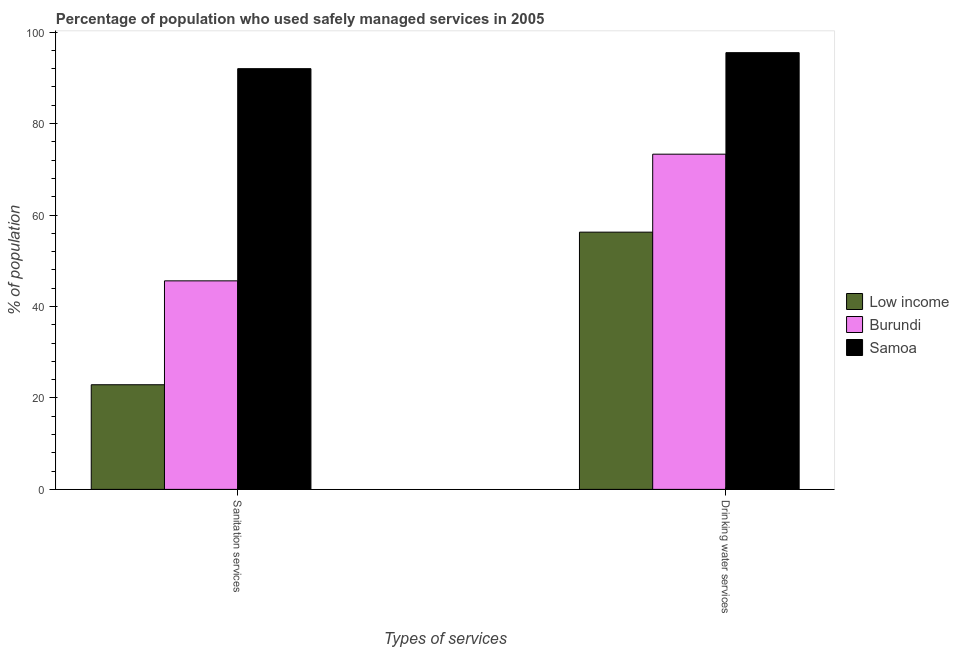How many different coloured bars are there?
Offer a very short reply. 3. How many bars are there on the 2nd tick from the right?
Provide a succinct answer. 3. What is the label of the 2nd group of bars from the left?
Offer a very short reply. Drinking water services. What is the percentage of population who used sanitation services in Samoa?
Provide a short and direct response. 92. Across all countries, what is the maximum percentage of population who used drinking water services?
Your response must be concise. 95.5. Across all countries, what is the minimum percentage of population who used sanitation services?
Offer a very short reply. 22.88. In which country was the percentage of population who used sanitation services maximum?
Give a very brief answer. Samoa. What is the total percentage of population who used sanitation services in the graph?
Your response must be concise. 160.48. What is the difference between the percentage of population who used drinking water services in Burundi and that in Samoa?
Give a very brief answer. -22.2. What is the difference between the percentage of population who used sanitation services in Burundi and the percentage of population who used drinking water services in Samoa?
Your response must be concise. -49.9. What is the average percentage of population who used drinking water services per country?
Your answer should be compact. 75.02. What is the difference between the percentage of population who used sanitation services and percentage of population who used drinking water services in Low income?
Your answer should be very brief. -33.37. What is the ratio of the percentage of population who used sanitation services in Samoa to that in Burundi?
Provide a short and direct response. 2.02. In how many countries, is the percentage of population who used drinking water services greater than the average percentage of population who used drinking water services taken over all countries?
Make the answer very short. 1. What does the 3rd bar from the left in Sanitation services represents?
Give a very brief answer. Samoa. What does the 2nd bar from the right in Sanitation services represents?
Ensure brevity in your answer.  Burundi. How many bars are there?
Make the answer very short. 6. How many countries are there in the graph?
Your response must be concise. 3. What is the difference between two consecutive major ticks on the Y-axis?
Provide a succinct answer. 20. Are the values on the major ticks of Y-axis written in scientific E-notation?
Give a very brief answer. No. Does the graph contain any zero values?
Your answer should be compact. No. Does the graph contain grids?
Make the answer very short. No. How many legend labels are there?
Your response must be concise. 3. How are the legend labels stacked?
Offer a very short reply. Vertical. What is the title of the graph?
Provide a succinct answer. Percentage of population who used safely managed services in 2005. Does "Albania" appear as one of the legend labels in the graph?
Offer a terse response. No. What is the label or title of the X-axis?
Your response must be concise. Types of services. What is the label or title of the Y-axis?
Keep it short and to the point. % of population. What is the % of population in Low income in Sanitation services?
Keep it short and to the point. 22.88. What is the % of population in Burundi in Sanitation services?
Provide a succinct answer. 45.6. What is the % of population in Samoa in Sanitation services?
Your answer should be very brief. 92. What is the % of population of Low income in Drinking water services?
Ensure brevity in your answer.  56.25. What is the % of population in Burundi in Drinking water services?
Make the answer very short. 73.3. What is the % of population in Samoa in Drinking water services?
Keep it short and to the point. 95.5. Across all Types of services, what is the maximum % of population of Low income?
Provide a short and direct response. 56.25. Across all Types of services, what is the maximum % of population of Burundi?
Provide a short and direct response. 73.3. Across all Types of services, what is the maximum % of population of Samoa?
Your response must be concise. 95.5. Across all Types of services, what is the minimum % of population in Low income?
Make the answer very short. 22.88. Across all Types of services, what is the minimum % of population in Burundi?
Ensure brevity in your answer.  45.6. Across all Types of services, what is the minimum % of population of Samoa?
Provide a succinct answer. 92. What is the total % of population in Low income in the graph?
Give a very brief answer. 79.13. What is the total % of population in Burundi in the graph?
Offer a terse response. 118.9. What is the total % of population of Samoa in the graph?
Keep it short and to the point. 187.5. What is the difference between the % of population of Low income in Sanitation services and that in Drinking water services?
Your answer should be compact. -33.37. What is the difference between the % of population in Burundi in Sanitation services and that in Drinking water services?
Your answer should be very brief. -27.7. What is the difference between the % of population in Low income in Sanitation services and the % of population in Burundi in Drinking water services?
Your answer should be very brief. -50.42. What is the difference between the % of population in Low income in Sanitation services and the % of population in Samoa in Drinking water services?
Keep it short and to the point. -72.62. What is the difference between the % of population in Burundi in Sanitation services and the % of population in Samoa in Drinking water services?
Offer a very short reply. -49.9. What is the average % of population in Low income per Types of services?
Provide a short and direct response. 39.57. What is the average % of population of Burundi per Types of services?
Offer a terse response. 59.45. What is the average % of population in Samoa per Types of services?
Your answer should be very brief. 93.75. What is the difference between the % of population in Low income and % of population in Burundi in Sanitation services?
Provide a short and direct response. -22.72. What is the difference between the % of population of Low income and % of population of Samoa in Sanitation services?
Give a very brief answer. -69.12. What is the difference between the % of population of Burundi and % of population of Samoa in Sanitation services?
Ensure brevity in your answer.  -46.4. What is the difference between the % of population of Low income and % of population of Burundi in Drinking water services?
Give a very brief answer. -17.05. What is the difference between the % of population of Low income and % of population of Samoa in Drinking water services?
Offer a terse response. -39.25. What is the difference between the % of population in Burundi and % of population in Samoa in Drinking water services?
Your answer should be very brief. -22.2. What is the ratio of the % of population of Low income in Sanitation services to that in Drinking water services?
Offer a very short reply. 0.41. What is the ratio of the % of population in Burundi in Sanitation services to that in Drinking water services?
Keep it short and to the point. 0.62. What is the ratio of the % of population of Samoa in Sanitation services to that in Drinking water services?
Your answer should be compact. 0.96. What is the difference between the highest and the second highest % of population of Low income?
Offer a terse response. 33.37. What is the difference between the highest and the second highest % of population in Burundi?
Your response must be concise. 27.7. What is the difference between the highest and the lowest % of population of Low income?
Provide a short and direct response. 33.37. What is the difference between the highest and the lowest % of population of Burundi?
Offer a very short reply. 27.7. What is the difference between the highest and the lowest % of population of Samoa?
Ensure brevity in your answer.  3.5. 